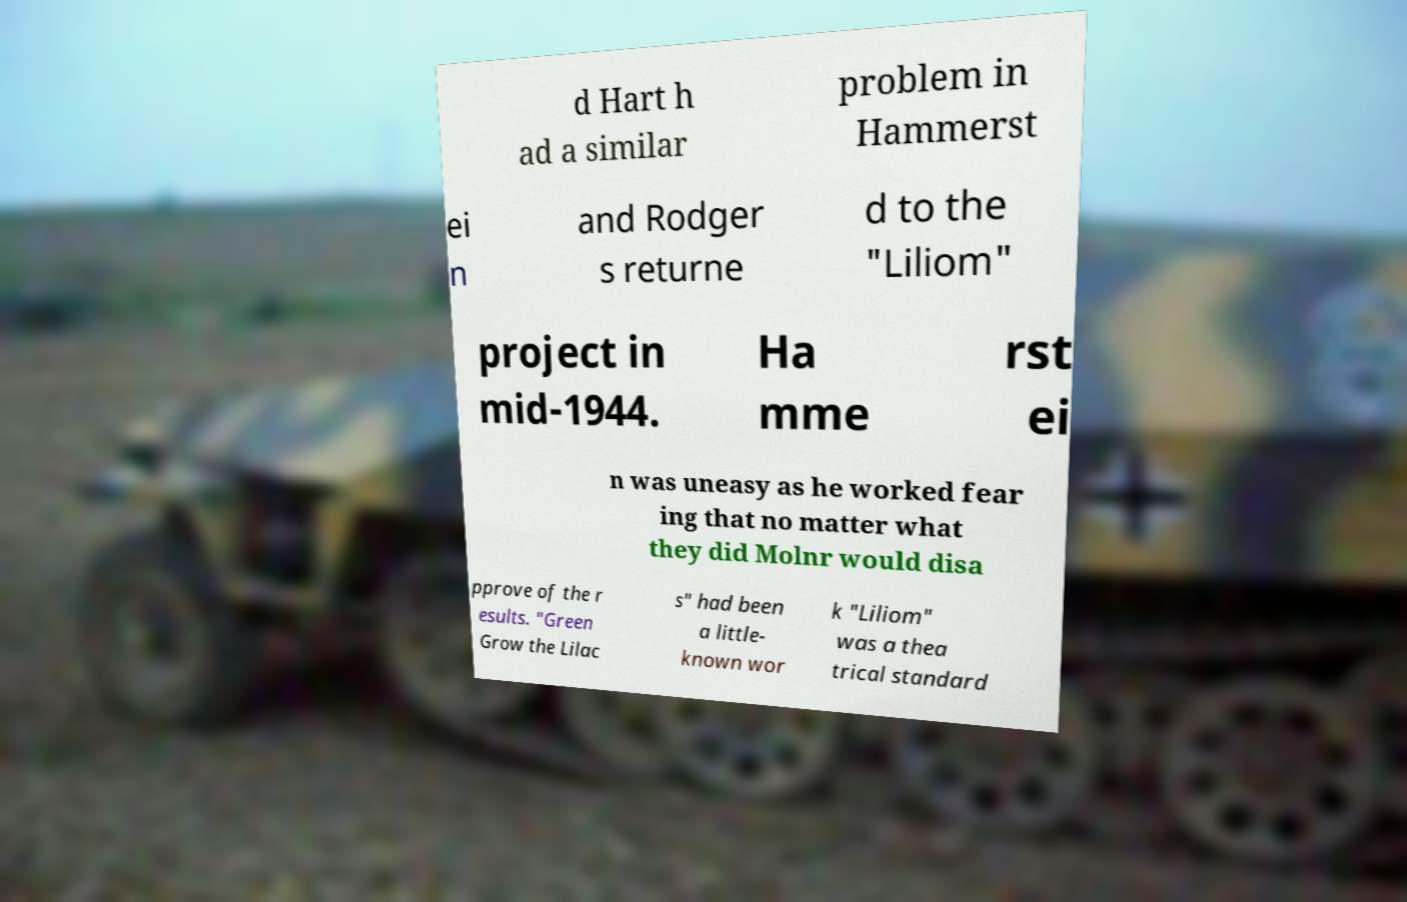Please identify and transcribe the text found in this image. d Hart h ad a similar problem in Hammerst ei n and Rodger s returne d to the "Liliom" project in mid-1944. Ha mme rst ei n was uneasy as he worked fear ing that no matter what they did Molnr would disa pprove of the r esults. "Green Grow the Lilac s" had been a little- known wor k "Liliom" was a thea trical standard 